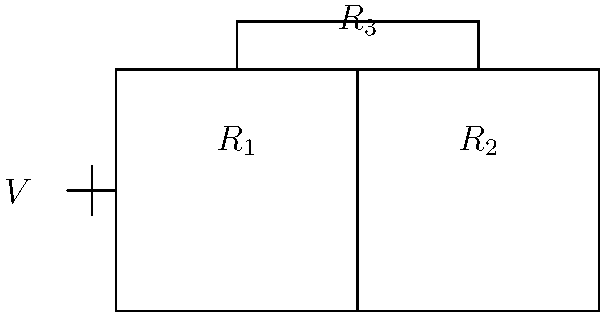As a music distributor, you're organizing a playlist system for store owners. The system's circuitry includes three parallel resistors representing different music genres. If $R_1 = 6\Omega$ (representing pop), $R_2 = 12\Omega$ (representing rock), and $R_3 = 4\Omega$ (representing jazz), what is the total resistance of this parallel circuit? To calculate the total resistance in a parallel circuit, we use the formula:

$$\frac{1}{R_{total}} = \frac{1}{R_1} + \frac{1}{R_2} + \frac{1}{R_3}$$

Let's solve this step-by-step:

1) Substitute the given values:
   $$\frac{1}{R_{total}} = \frac{1}{6\Omega} + \frac{1}{12\Omega} + \frac{1}{4\Omega}$$

2) Find a common denominator (LCD = 12):
   $$\frac{1}{R_{total}} = \frac{2}{12\Omega} + \frac{1}{12\Omega} + \frac{3}{12\Omega}$$

3) Add the fractions:
   $$\frac{1}{R_{total}} = \frac{6}{12\Omega} = \frac{1}{2\Omega}$$

4) Take the reciprocal of both sides:
   $$R_{total} = 2\Omega$$

Therefore, the total resistance of the parallel circuit is 2Ω.
Answer: $2\Omega$ 